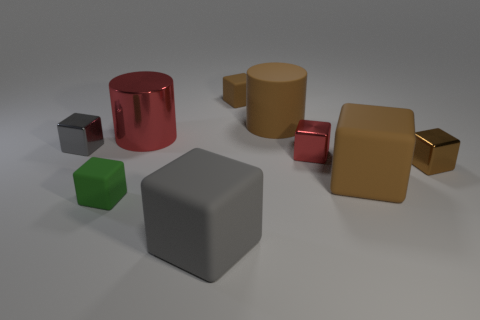What might be the purpose of arranging these objects like this? Such an arrangement might be for an art installation, a computer graphics rendering exercise, or a physical representation of different geometric shapes arranged aesthetically for demonstration or educational purposes. If this were part of a learning module, what concepts could be taught with it? This could be used to teach various concepts such as geometric shapes, 3D modeling, the properties of light and how it interacts with different materials, reflection, and refraction, as well as color theory and composition in a visual arts context. 